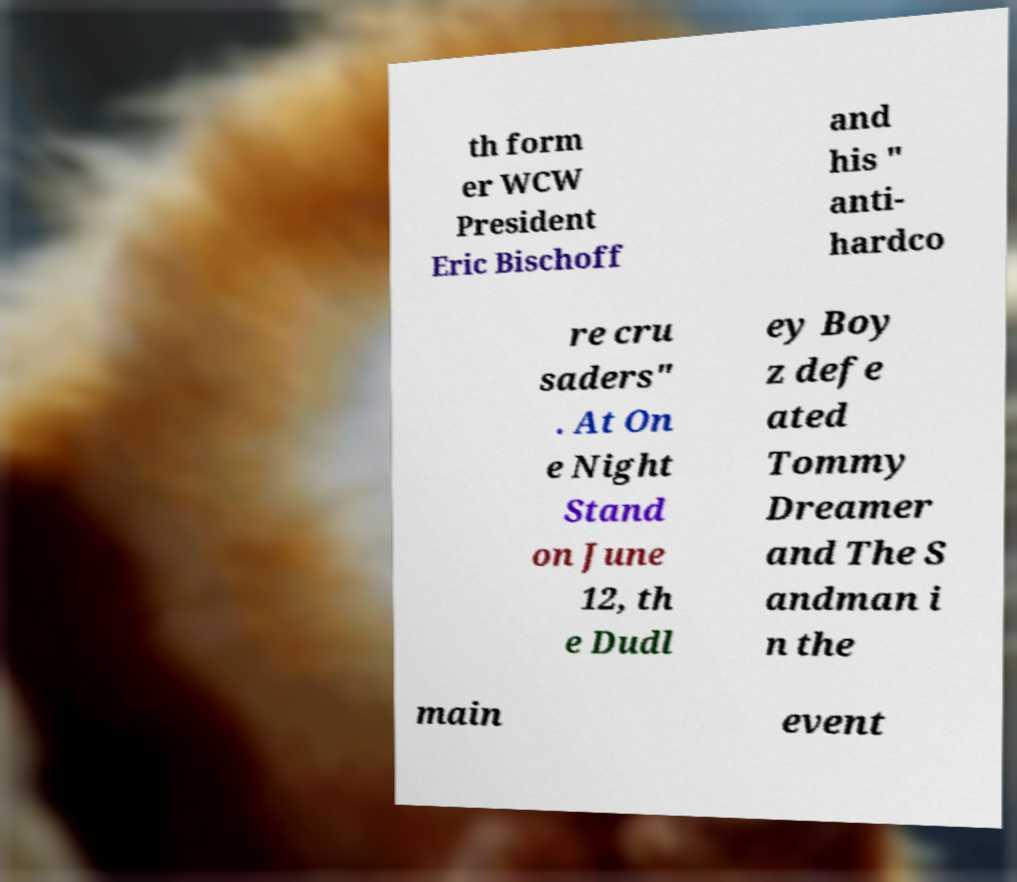I need the written content from this picture converted into text. Can you do that? th form er WCW President Eric Bischoff and his " anti- hardco re cru saders" . At On e Night Stand on June 12, th e Dudl ey Boy z defe ated Tommy Dreamer and The S andman i n the main event 